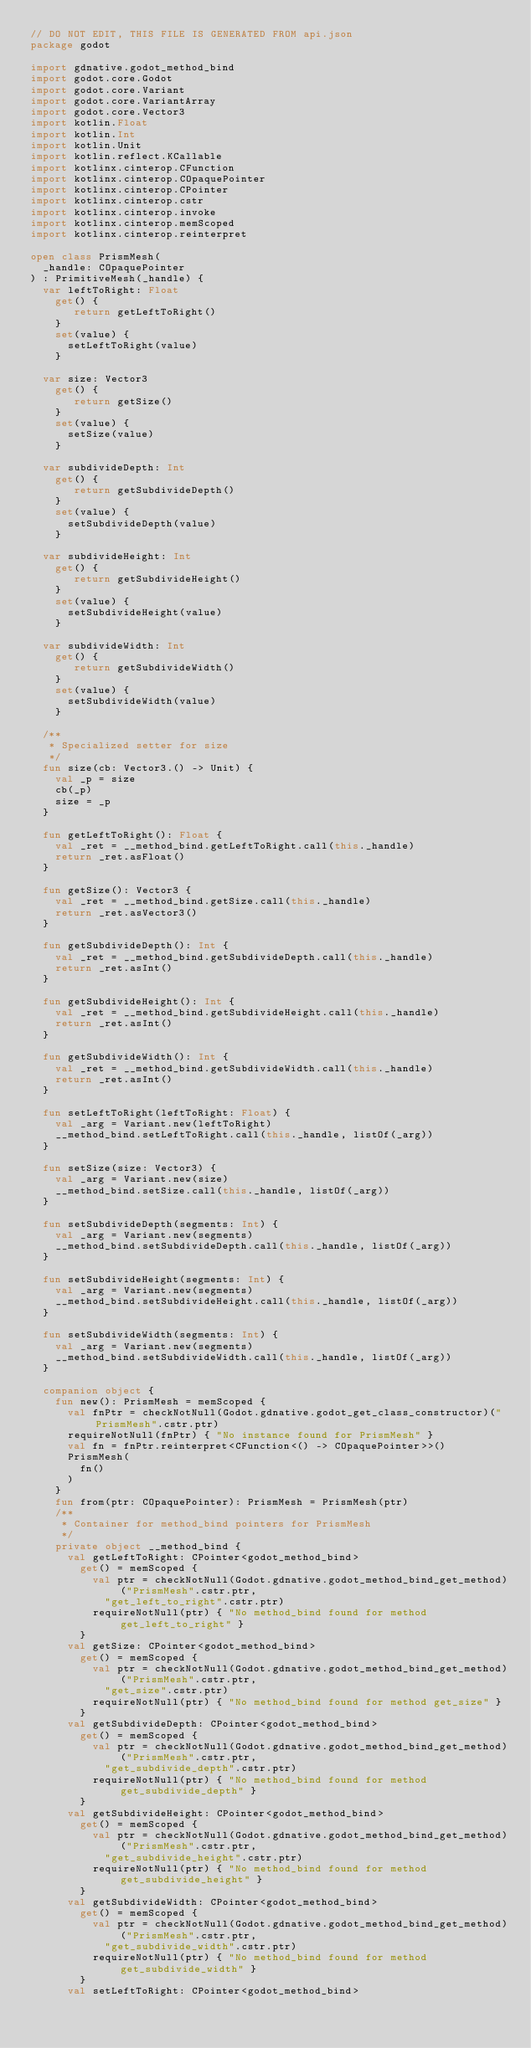Convert code to text. <code><loc_0><loc_0><loc_500><loc_500><_Kotlin_>// DO NOT EDIT, THIS FILE IS GENERATED FROM api.json
package godot

import gdnative.godot_method_bind
import godot.core.Godot
import godot.core.Variant
import godot.core.VariantArray
import godot.core.Vector3
import kotlin.Float
import kotlin.Int
import kotlin.Unit
import kotlin.reflect.KCallable
import kotlinx.cinterop.CFunction
import kotlinx.cinterop.COpaquePointer
import kotlinx.cinterop.CPointer
import kotlinx.cinterop.cstr
import kotlinx.cinterop.invoke
import kotlinx.cinterop.memScoped
import kotlinx.cinterop.reinterpret

open class PrismMesh(
  _handle: COpaquePointer
) : PrimitiveMesh(_handle) {
  var leftToRight: Float
    get() {
       return getLeftToRight() 
    }
    set(value) {
      setLeftToRight(value)
    }

  var size: Vector3
    get() {
       return getSize() 
    }
    set(value) {
      setSize(value)
    }

  var subdivideDepth: Int
    get() {
       return getSubdivideDepth() 
    }
    set(value) {
      setSubdivideDepth(value)
    }

  var subdivideHeight: Int
    get() {
       return getSubdivideHeight() 
    }
    set(value) {
      setSubdivideHeight(value)
    }

  var subdivideWidth: Int
    get() {
       return getSubdivideWidth() 
    }
    set(value) {
      setSubdivideWidth(value)
    }

  /**
   * Specialized setter for size
   */
  fun size(cb: Vector3.() -> Unit) {
    val _p = size
    cb(_p)
    size = _p
  }

  fun getLeftToRight(): Float {
    val _ret = __method_bind.getLeftToRight.call(this._handle)
    return _ret.asFloat()
  }

  fun getSize(): Vector3 {
    val _ret = __method_bind.getSize.call(this._handle)
    return _ret.asVector3()
  }

  fun getSubdivideDepth(): Int {
    val _ret = __method_bind.getSubdivideDepth.call(this._handle)
    return _ret.asInt()
  }

  fun getSubdivideHeight(): Int {
    val _ret = __method_bind.getSubdivideHeight.call(this._handle)
    return _ret.asInt()
  }

  fun getSubdivideWidth(): Int {
    val _ret = __method_bind.getSubdivideWidth.call(this._handle)
    return _ret.asInt()
  }

  fun setLeftToRight(leftToRight: Float) {
    val _arg = Variant.new(leftToRight)
    __method_bind.setLeftToRight.call(this._handle, listOf(_arg))
  }

  fun setSize(size: Vector3) {
    val _arg = Variant.new(size)
    __method_bind.setSize.call(this._handle, listOf(_arg))
  }

  fun setSubdivideDepth(segments: Int) {
    val _arg = Variant.new(segments)
    __method_bind.setSubdivideDepth.call(this._handle, listOf(_arg))
  }

  fun setSubdivideHeight(segments: Int) {
    val _arg = Variant.new(segments)
    __method_bind.setSubdivideHeight.call(this._handle, listOf(_arg))
  }

  fun setSubdivideWidth(segments: Int) {
    val _arg = Variant.new(segments)
    __method_bind.setSubdivideWidth.call(this._handle, listOf(_arg))
  }

  companion object {
    fun new(): PrismMesh = memScoped {
      val fnPtr = checkNotNull(Godot.gdnative.godot_get_class_constructor)("PrismMesh".cstr.ptr)
      requireNotNull(fnPtr) { "No instance found for PrismMesh" }
      val fn = fnPtr.reinterpret<CFunction<() -> COpaquePointer>>()
      PrismMesh(
        fn()
      )
    }
    fun from(ptr: COpaquePointer): PrismMesh = PrismMesh(ptr)
    /**
     * Container for method_bind pointers for PrismMesh
     */
    private object __method_bind {
      val getLeftToRight: CPointer<godot_method_bind>
        get() = memScoped {
          val ptr = checkNotNull(Godot.gdnative.godot_method_bind_get_method)("PrismMesh".cstr.ptr,
            "get_left_to_right".cstr.ptr)
          requireNotNull(ptr) { "No method_bind found for method get_left_to_right" }
        }
      val getSize: CPointer<godot_method_bind>
        get() = memScoped {
          val ptr = checkNotNull(Godot.gdnative.godot_method_bind_get_method)("PrismMesh".cstr.ptr,
            "get_size".cstr.ptr)
          requireNotNull(ptr) { "No method_bind found for method get_size" }
        }
      val getSubdivideDepth: CPointer<godot_method_bind>
        get() = memScoped {
          val ptr = checkNotNull(Godot.gdnative.godot_method_bind_get_method)("PrismMesh".cstr.ptr,
            "get_subdivide_depth".cstr.ptr)
          requireNotNull(ptr) { "No method_bind found for method get_subdivide_depth" }
        }
      val getSubdivideHeight: CPointer<godot_method_bind>
        get() = memScoped {
          val ptr = checkNotNull(Godot.gdnative.godot_method_bind_get_method)("PrismMesh".cstr.ptr,
            "get_subdivide_height".cstr.ptr)
          requireNotNull(ptr) { "No method_bind found for method get_subdivide_height" }
        }
      val getSubdivideWidth: CPointer<godot_method_bind>
        get() = memScoped {
          val ptr = checkNotNull(Godot.gdnative.godot_method_bind_get_method)("PrismMesh".cstr.ptr,
            "get_subdivide_width".cstr.ptr)
          requireNotNull(ptr) { "No method_bind found for method get_subdivide_width" }
        }
      val setLeftToRight: CPointer<godot_method_bind></code> 